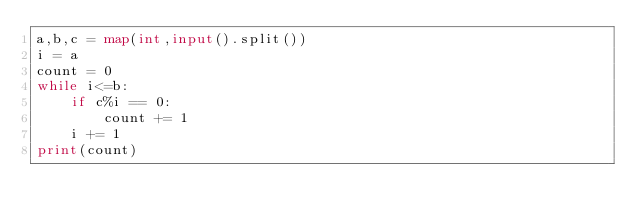<code> <loc_0><loc_0><loc_500><loc_500><_Python_>a,b,c = map(int,input().split())
i = a
count = 0
while i<=b:
    if c%i == 0:
        count += 1
    i += 1
print(count)
</code> 